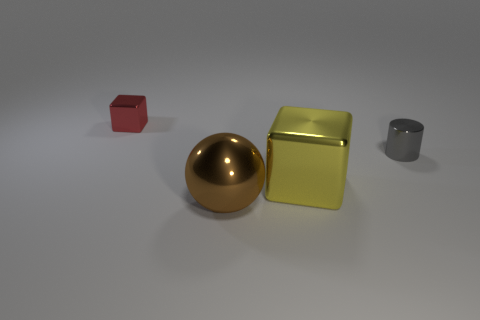Add 3 big gray matte blocks. How many objects exist? 7 Subtract all balls. How many objects are left? 3 Add 3 brown metal things. How many brown metal things exist? 4 Subtract 0 blue cubes. How many objects are left? 4 Subtract all red shiny things. Subtract all yellow blocks. How many objects are left? 2 Add 1 large blocks. How many large blocks are left? 2 